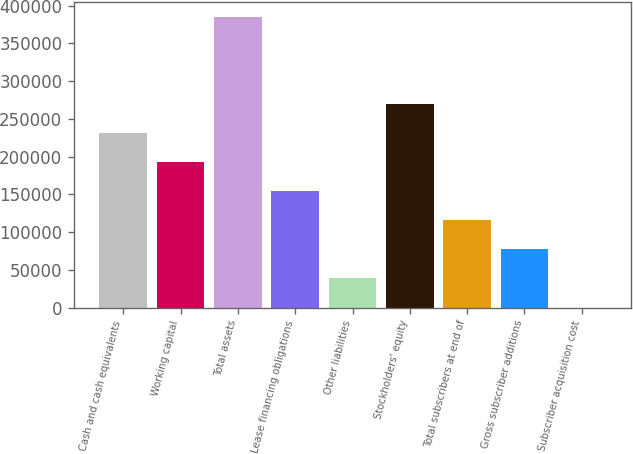<chart> <loc_0><loc_0><loc_500><loc_500><bar_chart><fcel>Cash and cash equivalents<fcel>Working capital<fcel>Total assets<fcel>Lease financing obligations<fcel>Other liabilities<fcel>Stockholders' equity<fcel>Total subscribers at end of<fcel>Gross subscriber additions<fcel>Subscriber acquisition cost<nl><fcel>231084<fcel>192576<fcel>385114<fcel>154069<fcel>38546.3<fcel>269591<fcel>115561<fcel>77053.8<fcel>38.78<nl></chart> 